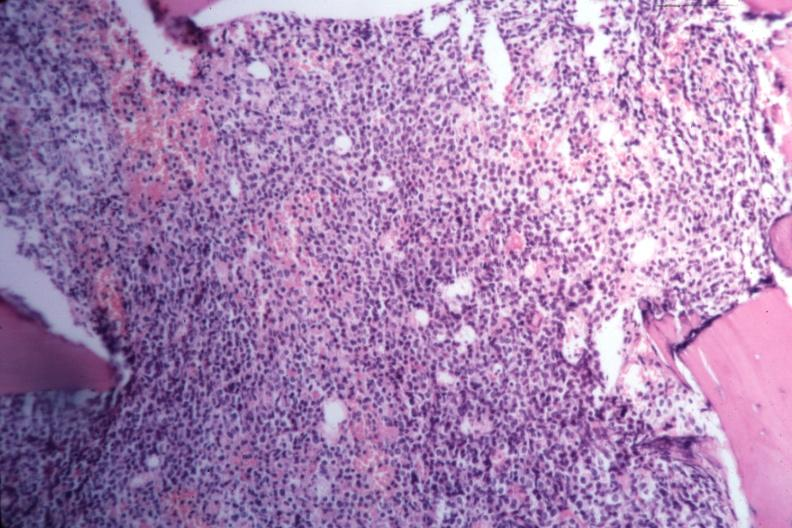s acute myelogenous leukemia present?
Answer the question using a single word or phrase. Yes 